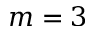<formula> <loc_0><loc_0><loc_500><loc_500>m = 3</formula> 